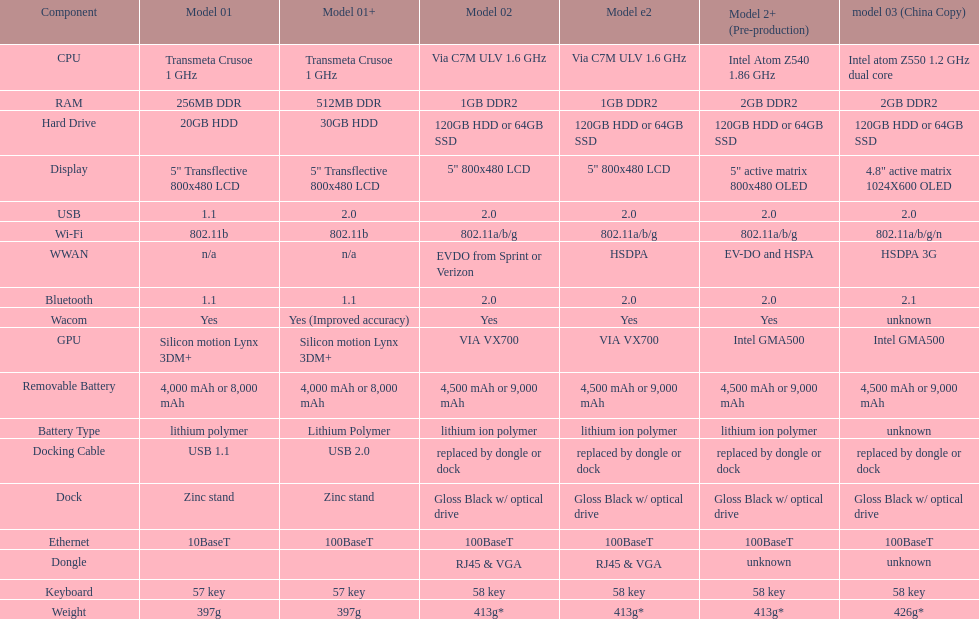Give me the full table as a dictionary. {'header': ['Component', 'Model 01', 'Model 01+', 'Model 02', 'Model e2', 'Model 2+ (Pre-production)', 'model 03 (China Copy)'], 'rows': [['CPU', 'Transmeta Crusoe 1\xa0GHz', 'Transmeta Crusoe 1\xa0GHz', 'Via C7M ULV 1.6\xa0GHz', 'Via C7M ULV 1.6\xa0GHz', 'Intel Atom Z540 1.86\xa0GHz', 'Intel atom Z550 1.2\xa0GHz dual core'], ['RAM', '256MB DDR', '512MB DDR', '1GB DDR2', '1GB DDR2', '2GB DDR2', '2GB DDR2'], ['Hard Drive', '20GB HDD', '30GB HDD', '120GB HDD or 64GB SSD', '120GB HDD or 64GB SSD', '120GB HDD or 64GB SSD', '120GB HDD or 64GB SSD'], ['Display', '5" Transflective 800x480 LCD', '5" Transflective 800x480 LCD', '5" 800x480 LCD', '5" 800x480 LCD', '5" active matrix 800x480 OLED', '4.8" active matrix 1024X600 OLED'], ['USB', '1.1', '2.0', '2.0', '2.0', '2.0', '2.0'], ['Wi-Fi', '802.11b', '802.11b', '802.11a/b/g', '802.11a/b/g', '802.11a/b/g', '802.11a/b/g/n'], ['WWAN', 'n/a', 'n/a', 'EVDO from Sprint or Verizon', 'HSDPA', 'EV-DO and HSPA', 'HSDPA 3G'], ['Bluetooth', '1.1', '1.1', '2.0', '2.0', '2.0', '2.1'], ['Wacom', 'Yes', 'Yes (Improved accuracy)', 'Yes', 'Yes', 'Yes', 'unknown'], ['GPU', 'Silicon motion Lynx 3DM+', 'Silicon motion Lynx 3DM+', 'VIA VX700', 'VIA VX700', 'Intel GMA500', 'Intel GMA500'], ['Removable Battery', '4,000 mAh or 8,000 mAh', '4,000 mAh or 8,000 mAh', '4,500 mAh or 9,000 mAh', '4,500 mAh or 9,000 mAh', '4,500 mAh or 9,000 mAh', '4,500 mAh or 9,000 mAh'], ['Battery Type', 'lithium polymer', 'Lithium Polymer', 'lithium ion polymer', 'lithium ion polymer', 'lithium ion polymer', 'unknown'], ['Docking Cable', 'USB 1.1', 'USB 2.0', 'replaced by dongle or dock', 'replaced by dongle or dock', 'replaced by dongle or dock', 'replaced by dongle or dock'], ['Dock', 'Zinc stand', 'Zinc stand', 'Gloss Black w/ optical drive', 'Gloss Black w/ optical drive', 'Gloss Black w/ optical drive', 'Gloss Black w/ optical drive'], ['Ethernet', '10BaseT', '100BaseT', '100BaseT', '100BaseT', '100BaseT', '100BaseT'], ['Dongle', '', '', 'RJ45 & VGA', 'RJ45 & VGA', 'unknown', 'unknown'], ['Keyboard', '57 key', '57 key', '58 key', '58 key', '58 key', '58 key'], ['Weight', '397g', '397g', '413g*', '413g*', '413g*', '426g*']]} What is the average number of models that have usb 2.0? 5. 